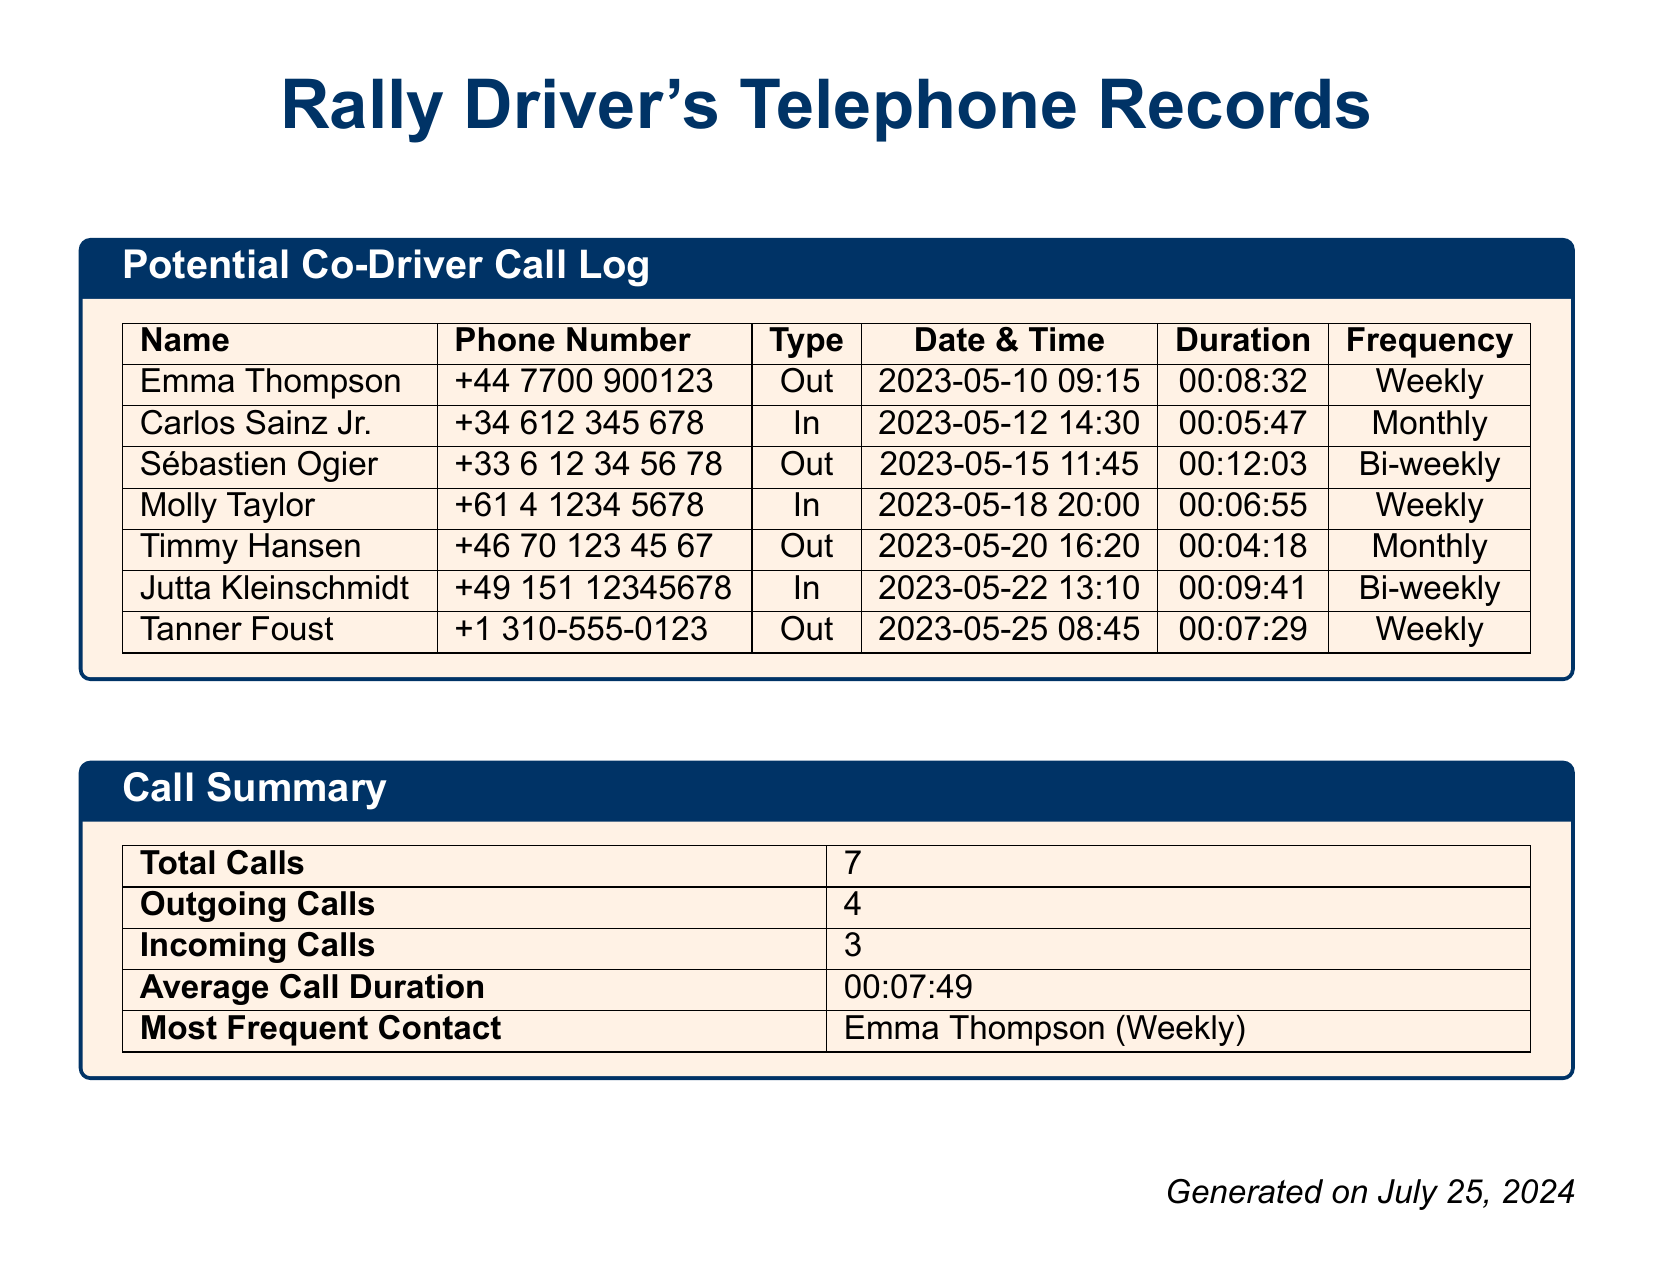What is the name of the most frequent contact? The most frequent contact is listed in the call summary section of the document.
Answer: Emma Thompson How many total calls were recorded? The total number of calls is summarized in the call summary.
Answer: 7 What was the duration of the call with Sébastien Ogier? The duration of the call is specified in the potential co-driver call log for Sébastien Ogier.
Answer: 00:12:03 How often does Timmy Hansen receive calls? The frequency of calls to Timmy Hansen can be found in the call log.
Answer: Monthly What is the average call duration? The average call duration is calculated and found in the call summary section.
Answer: 00:07:49 What date was the call with Jutta Kleinschmidt made? The date and time of the call with Jutta Kleinschmidt is shown in the log.
Answer: 2023-05-22 Which call had the shortest duration? The duration of each call is listed, and the shortest can be identified from these records.
Answer: 00:04:18 